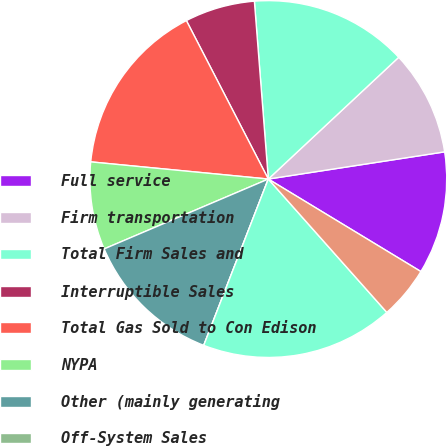Convert chart to OTSL. <chart><loc_0><loc_0><loc_500><loc_500><pie_chart><fcel>Full service<fcel>Firm transportation<fcel>Total Firm Sales and<fcel>Interruptible Sales<fcel>Total Gas Sold to Con Edison<fcel>NYPA<fcel>Other (mainly generating<fcel>Off-System Sales<fcel>Total Sales and Transportation<fcel>Other operating revenues<nl><fcel>11.11%<fcel>9.52%<fcel>14.29%<fcel>6.35%<fcel>15.87%<fcel>7.94%<fcel>12.7%<fcel>0.0%<fcel>17.46%<fcel>4.76%<nl></chart> 